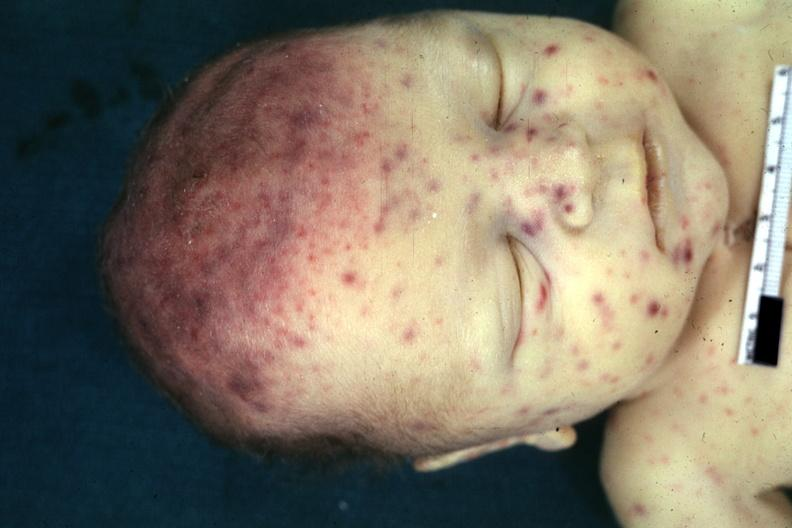what does this image show?
Answer the question using a single word or phrase. View of face with rash 